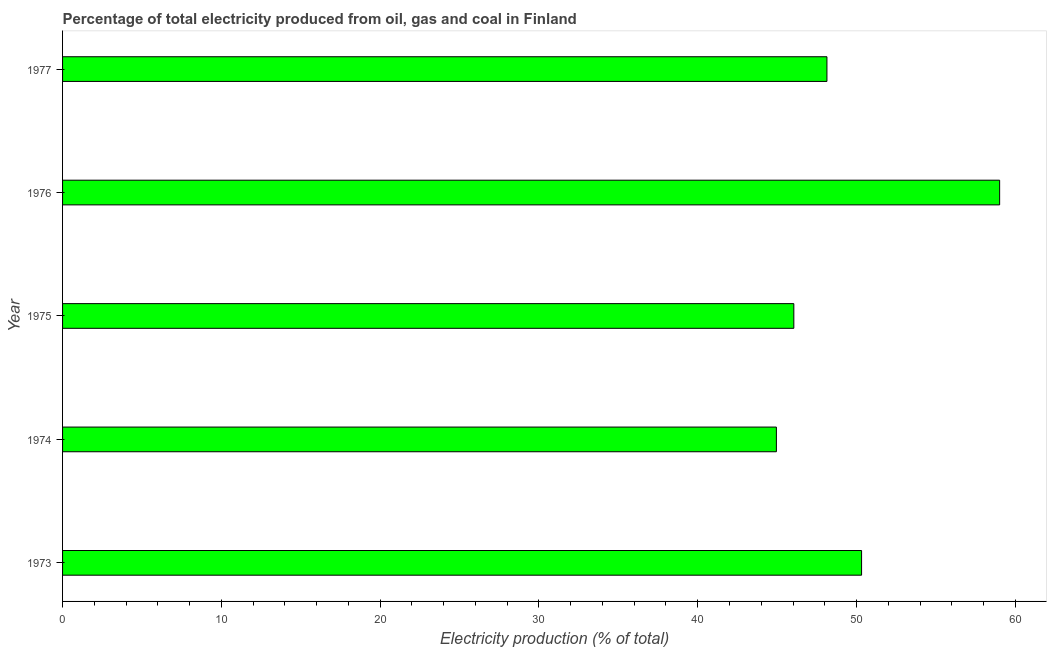Does the graph contain any zero values?
Provide a short and direct response. No. What is the title of the graph?
Make the answer very short. Percentage of total electricity produced from oil, gas and coal in Finland. What is the label or title of the X-axis?
Offer a very short reply. Electricity production (% of total). What is the label or title of the Y-axis?
Ensure brevity in your answer.  Year. What is the electricity production in 1975?
Your answer should be very brief. 46.05. Across all years, what is the maximum electricity production?
Your response must be concise. 59.01. Across all years, what is the minimum electricity production?
Give a very brief answer. 44.95. In which year was the electricity production maximum?
Your answer should be compact. 1976. In which year was the electricity production minimum?
Provide a short and direct response. 1974. What is the sum of the electricity production?
Your response must be concise. 248.47. What is the difference between the electricity production in 1973 and 1975?
Give a very brief answer. 4.27. What is the average electricity production per year?
Give a very brief answer. 49.69. What is the median electricity production?
Provide a short and direct response. 48.14. What is the ratio of the electricity production in 1974 to that in 1976?
Offer a very short reply. 0.76. Is the difference between the electricity production in 1976 and 1977 greater than the difference between any two years?
Your answer should be very brief. No. What is the difference between the highest and the second highest electricity production?
Your answer should be very brief. 8.69. Is the sum of the electricity production in 1973 and 1977 greater than the maximum electricity production across all years?
Your answer should be compact. Yes. What is the difference between the highest and the lowest electricity production?
Provide a succinct answer. 14.06. How many bars are there?
Provide a short and direct response. 5. Are all the bars in the graph horizontal?
Keep it short and to the point. Yes. How many years are there in the graph?
Your answer should be compact. 5. What is the Electricity production (% of total) of 1973?
Provide a short and direct response. 50.32. What is the Electricity production (% of total) of 1974?
Provide a succinct answer. 44.95. What is the Electricity production (% of total) in 1975?
Your answer should be compact. 46.05. What is the Electricity production (% of total) in 1976?
Offer a terse response. 59.01. What is the Electricity production (% of total) of 1977?
Ensure brevity in your answer.  48.14. What is the difference between the Electricity production (% of total) in 1973 and 1974?
Offer a terse response. 5.36. What is the difference between the Electricity production (% of total) in 1973 and 1975?
Keep it short and to the point. 4.27. What is the difference between the Electricity production (% of total) in 1973 and 1976?
Give a very brief answer. -8.69. What is the difference between the Electricity production (% of total) in 1973 and 1977?
Give a very brief answer. 2.18. What is the difference between the Electricity production (% of total) in 1974 and 1975?
Your answer should be very brief. -1.1. What is the difference between the Electricity production (% of total) in 1974 and 1976?
Your answer should be very brief. -14.06. What is the difference between the Electricity production (% of total) in 1974 and 1977?
Offer a terse response. -3.18. What is the difference between the Electricity production (% of total) in 1975 and 1976?
Offer a terse response. -12.96. What is the difference between the Electricity production (% of total) in 1975 and 1977?
Provide a short and direct response. -2.08. What is the difference between the Electricity production (% of total) in 1976 and 1977?
Make the answer very short. 10.88. What is the ratio of the Electricity production (% of total) in 1973 to that in 1974?
Give a very brief answer. 1.12. What is the ratio of the Electricity production (% of total) in 1973 to that in 1975?
Ensure brevity in your answer.  1.09. What is the ratio of the Electricity production (% of total) in 1973 to that in 1976?
Your response must be concise. 0.85. What is the ratio of the Electricity production (% of total) in 1973 to that in 1977?
Provide a short and direct response. 1.04. What is the ratio of the Electricity production (% of total) in 1974 to that in 1976?
Offer a terse response. 0.76. What is the ratio of the Electricity production (% of total) in 1974 to that in 1977?
Give a very brief answer. 0.93. What is the ratio of the Electricity production (% of total) in 1975 to that in 1976?
Make the answer very short. 0.78. What is the ratio of the Electricity production (% of total) in 1975 to that in 1977?
Offer a very short reply. 0.96. What is the ratio of the Electricity production (% of total) in 1976 to that in 1977?
Provide a succinct answer. 1.23. 